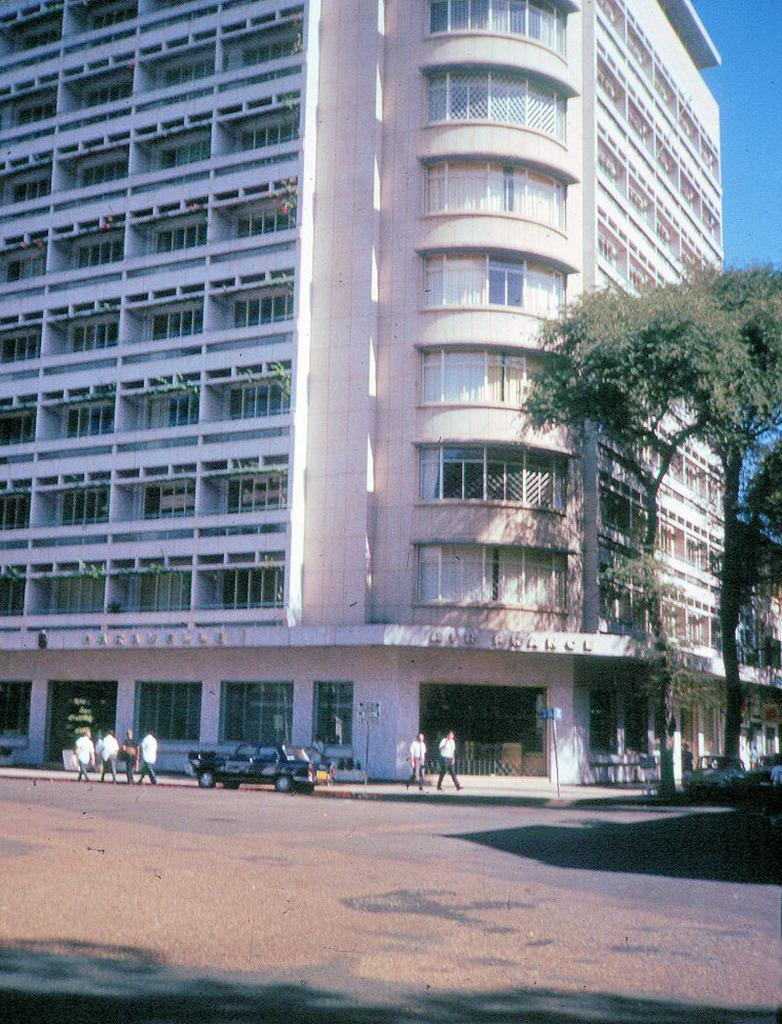What type of structure is visible in the image? There is a building in the image. Can you describe the building's appearance? The building has multiple windows. What else can be seen in the image besides the building? There are trees, the sky, shadows, a vehicle, and people standing in the image. What type of wire is being used to smash the building in the image? There is no wire or smashing of the building present in the image. 